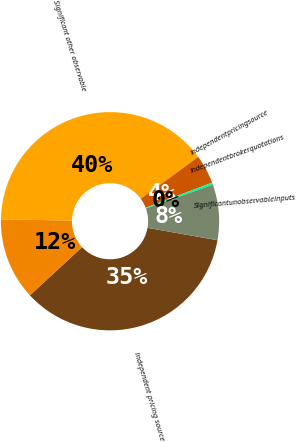Convert chart to OTSL. <chart><loc_0><loc_0><loc_500><loc_500><pie_chart><fcel>Independent pricing source<fcel>Unnamed: 1<fcel>Significant other observable<fcel>Independentpricingsource<fcel>Independentbrokerquotations<fcel>Significantunobservableinputs<nl><fcel>35.34%<fcel>12.15%<fcel>39.7%<fcel>4.27%<fcel>0.33%<fcel>8.21%<nl></chart> 